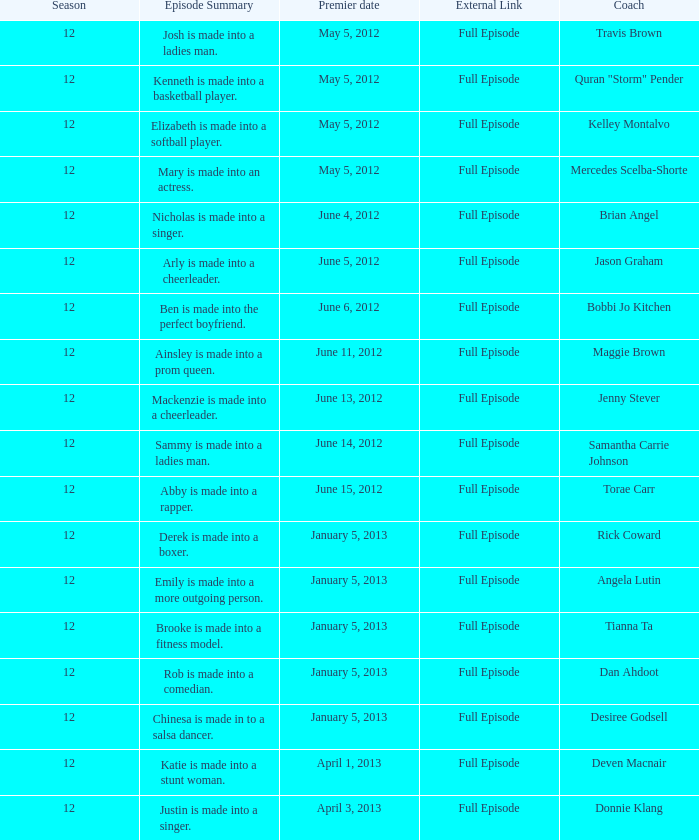What is the title of the episode featuring travis brown? 1.0. 